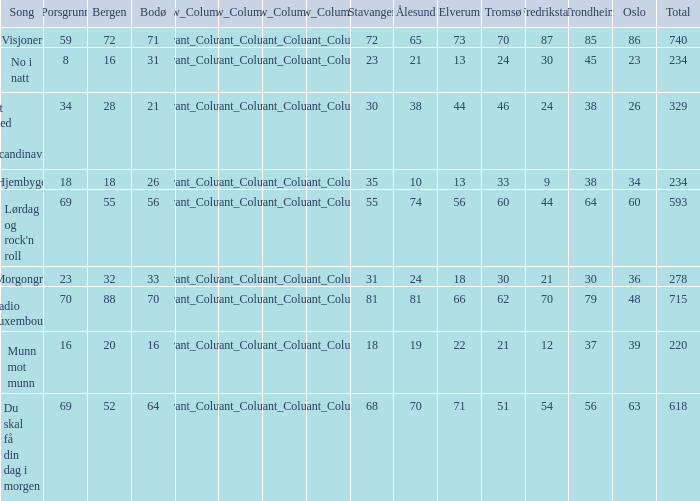When oslo is 48, what is stavanger? 81.0. 